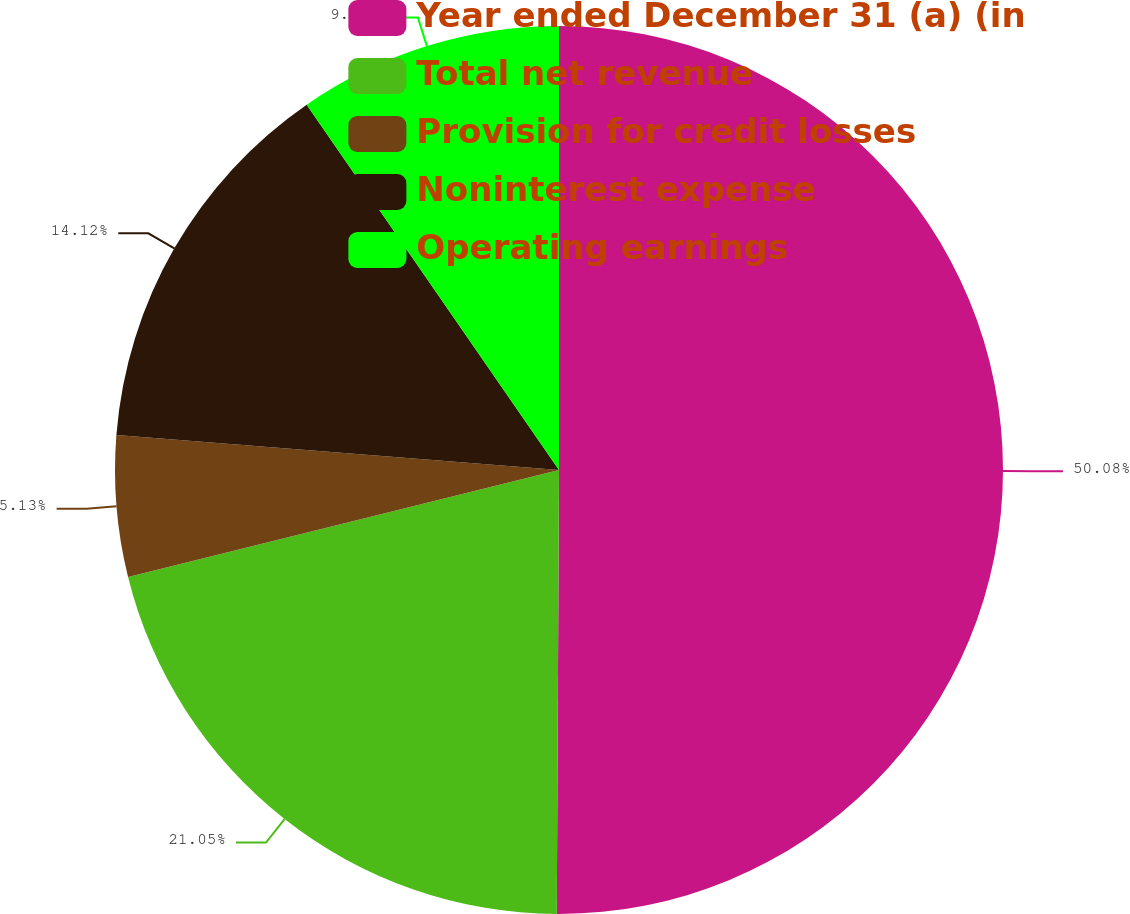Convert chart. <chart><loc_0><loc_0><loc_500><loc_500><pie_chart><fcel>Year ended December 31 (a) (in<fcel>Total net revenue<fcel>Provision for credit losses<fcel>Noninterest expense<fcel>Operating earnings<nl><fcel>50.08%<fcel>21.05%<fcel>5.13%<fcel>14.12%<fcel>9.62%<nl></chart> 